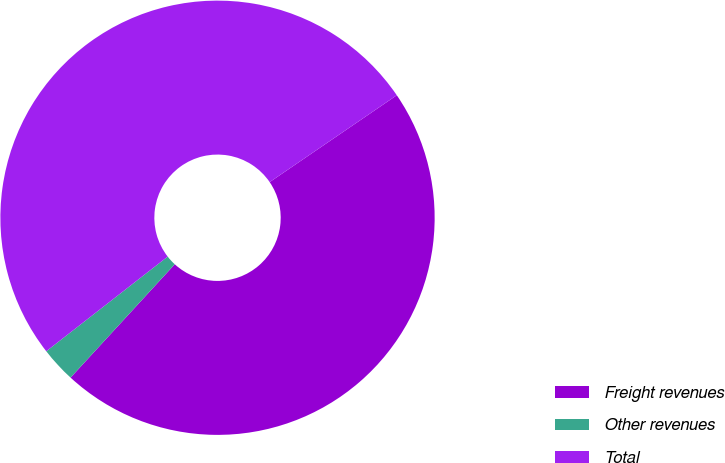Convert chart to OTSL. <chart><loc_0><loc_0><loc_500><loc_500><pie_chart><fcel>Freight revenues<fcel>Other revenues<fcel>Total<nl><fcel>46.37%<fcel>2.63%<fcel>51.0%<nl></chart> 